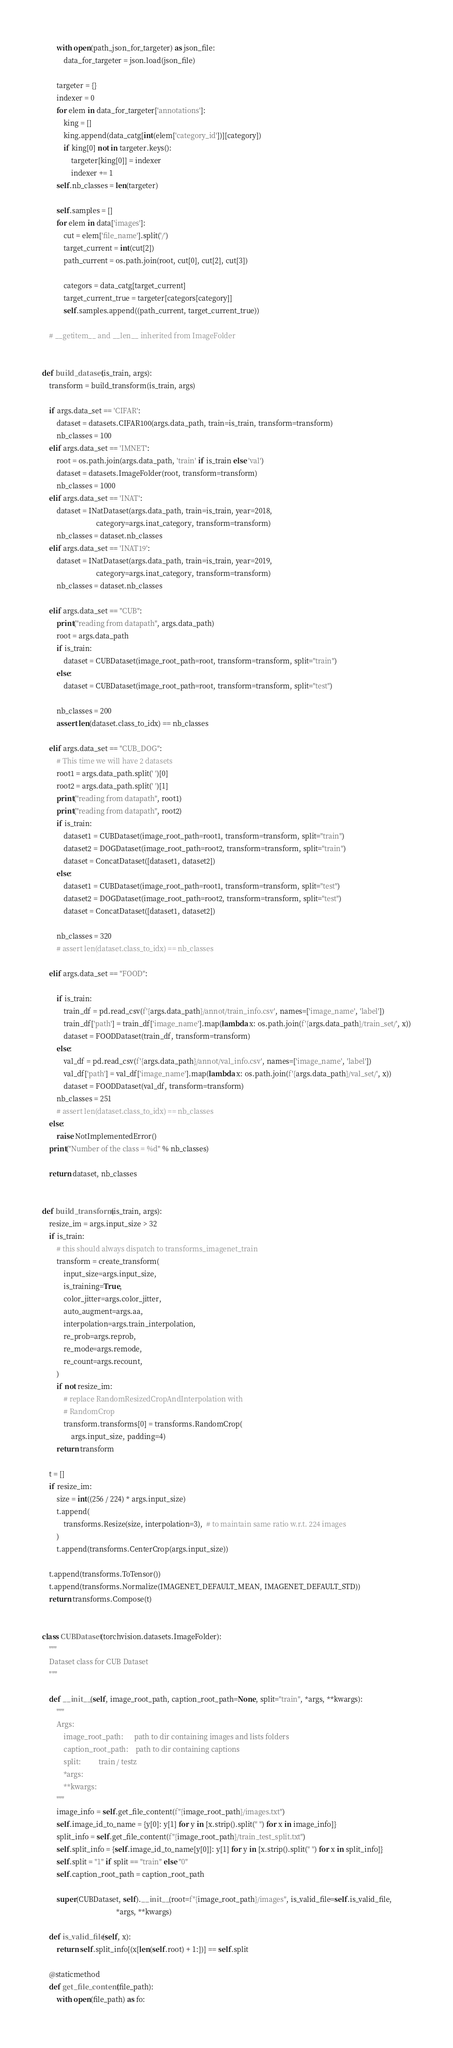<code> <loc_0><loc_0><loc_500><loc_500><_Python_>
        with open(path_json_for_targeter) as json_file:
            data_for_targeter = json.load(json_file)

        targeter = {}
        indexer = 0
        for elem in data_for_targeter['annotations']:
            king = []
            king.append(data_catg[int(elem['category_id'])][category])
            if king[0] not in targeter.keys():
                targeter[king[0]] = indexer
                indexer += 1
        self.nb_classes = len(targeter)

        self.samples = []
        for elem in data['images']:
            cut = elem['file_name'].split('/')
            target_current = int(cut[2])
            path_current = os.path.join(root, cut[0], cut[2], cut[3])

            categors = data_catg[target_current]
            target_current_true = targeter[categors[category]]
            self.samples.append((path_current, target_current_true))

    # __getitem__ and __len__ inherited from ImageFolder


def build_dataset(is_train, args):
    transform = build_transform(is_train, args)

    if args.data_set == 'CIFAR':
        dataset = datasets.CIFAR100(args.data_path, train=is_train, transform=transform)
        nb_classes = 100
    elif args.data_set == 'IMNET':
        root = os.path.join(args.data_path, 'train' if is_train else 'val')
        dataset = datasets.ImageFolder(root, transform=transform)
        nb_classes = 1000
    elif args.data_set == 'INAT':
        dataset = INatDataset(args.data_path, train=is_train, year=2018,
                              category=args.inat_category, transform=transform)
        nb_classes = dataset.nb_classes
    elif args.data_set == 'INAT19':
        dataset = INatDataset(args.data_path, train=is_train, year=2019,
                              category=args.inat_category, transform=transform)
        nb_classes = dataset.nb_classes

    elif args.data_set == "CUB":
        print("reading from datapath", args.data_path)
        root = args.data_path
        if is_train:
            dataset = CUBDataset(image_root_path=root, transform=transform, split="train")
        else:
            dataset = CUBDataset(image_root_path=root, transform=transform, split="test")

        nb_classes = 200
        assert len(dataset.class_to_idx) == nb_classes

    elif args.data_set == "CUB_DOG":
        # This time we will have 2 datasets
        root1 = args.data_path.split(' ')[0]
        root2 = args.data_path.split(' ')[1]
        print("reading from datapath", root1)
        print("reading from datapath", root2)
        if is_train:
            dataset1 = CUBDataset(image_root_path=root1, transform=transform, split="train")
            dataset2 = DOGDataset(image_root_path=root2, transform=transform, split="train")
            dataset = ConcatDataset([dataset1, dataset2])
        else:
            dataset1 = CUBDataset(image_root_path=root1, transform=transform, split="test")
            dataset2 = DOGDataset(image_root_path=root2, transform=transform, split="test")
            dataset = ConcatDataset([dataset1, dataset2])

        nb_classes = 320
        # assert len(dataset.class_to_idx) == nb_classes

    elif args.data_set == "FOOD":

        if is_train:
            train_df = pd.read_csv(f'{args.data_path}/annot/train_info.csv', names=['image_name', 'label'])
            train_df['path'] = train_df['image_name'].map(lambda x: os.path.join(f'{args.data_path}/train_set/', x))
            dataset = FOODDataset(train_df, transform=transform)
        else:
            val_df = pd.read_csv(f'{args.data_path}/annot/val_info.csv', names=['image_name', 'label'])
            val_df['path'] = val_df['image_name'].map(lambda x: os.path.join(f'{args.data_path}/val_set/', x))
            dataset = FOODDataset(val_df, transform=transform)
        nb_classes = 251
        # assert len(dataset.class_to_idx) == nb_classes
    else:
        raise NotImplementedError()
    print("Number of the class = %d" % nb_classes)

    return dataset, nb_classes


def build_transform(is_train, args):
    resize_im = args.input_size > 32
    if is_train:
        # this should always dispatch to transforms_imagenet_train
        transform = create_transform(
            input_size=args.input_size,
            is_training=True,
            color_jitter=args.color_jitter,
            auto_augment=args.aa,
            interpolation=args.train_interpolation,
            re_prob=args.reprob,
            re_mode=args.remode,
            re_count=args.recount,
        )
        if not resize_im:
            # replace RandomResizedCropAndInterpolation with
            # RandomCrop
            transform.transforms[0] = transforms.RandomCrop(
                args.input_size, padding=4)
        return transform

    t = []
    if resize_im:
        size = int((256 / 224) * args.input_size)
        t.append(
            transforms.Resize(size, interpolation=3),  # to maintain same ratio w.r.t. 224 images
        )
        t.append(transforms.CenterCrop(args.input_size))

    t.append(transforms.ToTensor())
    t.append(transforms.Normalize(IMAGENET_DEFAULT_MEAN, IMAGENET_DEFAULT_STD))
    return transforms.Compose(t)


class CUBDataset(torchvision.datasets.ImageFolder):
    """
    Dataset class for CUB Dataset
    """

    def __init__(self, image_root_path, caption_root_path=None, split="train", *args, **kwargs):
        """
        Args:
            image_root_path:      path to dir containing images and lists folders
            caption_root_path:    path to dir containing captions
            split:          train / testz
            *args:
            **kwargs:
        """
        image_info = self.get_file_content(f"{image_root_path}/images.txt")
        self.image_id_to_name = {y[0]: y[1] for y in [x.strip().split(" ") for x in image_info]}
        split_info = self.get_file_content(f"{image_root_path}/train_test_split.txt")
        self.split_info = {self.image_id_to_name[y[0]]: y[1] for y in [x.strip().split(" ") for x in split_info]}
        self.split = "1" if split == "train" else "0"
        self.caption_root_path = caption_root_path

        super(CUBDataset, self).__init__(root=f"{image_root_path}/images", is_valid_file=self.is_valid_file,
                                         *args, **kwargs)

    def is_valid_file(self, x):
        return self.split_info[(x[len(self.root) + 1:])] == self.split

    @staticmethod
    def get_file_content(file_path):
        with open(file_path) as fo:</code> 